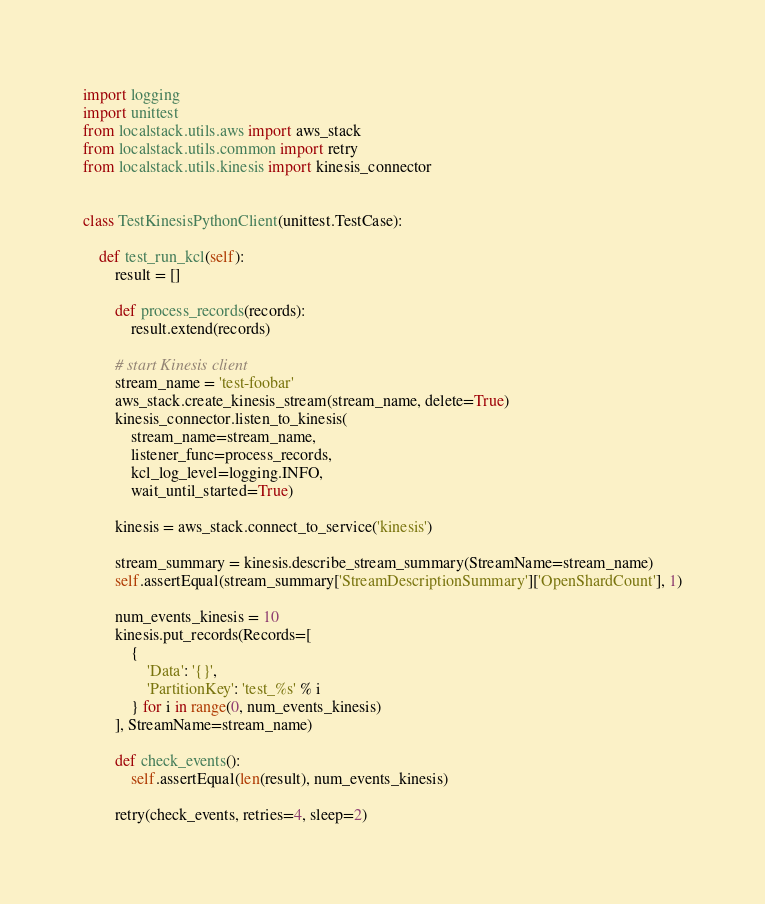<code> <loc_0><loc_0><loc_500><loc_500><_Python_>import logging
import unittest
from localstack.utils.aws import aws_stack
from localstack.utils.common import retry
from localstack.utils.kinesis import kinesis_connector


class TestKinesisPythonClient(unittest.TestCase):

    def test_run_kcl(self):
        result = []

        def process_records(records):
            result.extend(records)

        # start Kinesis client
        stream_name = 'test-foobar'
        aws_stack.create_kinesis_stream(stream_name, delete=True)
        kinesis_connector.listen_to_kinesis(
            stream_name=stream_name,
            listener_func=process_records,
            kcl_log_level=logging.INFO,
            wait_until_started=True)

        kinesis = aws_stack.connect_to_service('kinesis')

        stream_summary = kinesis.describe_stream_summary(StreamName=stream_name)
        self.assertEqual(stream_summary['StreamDescriptionSummary']['OpenShardCount'], 1)

        num_events_kinesis = 10
        kinesis.put_records(Records=[
            {
                'Data': '{}',
                'PartitionKey': 'test_%s' % i
            } for i in range(0, num_events_kinesis)
        ], StreamName=stream_name)

        def check_events():
            self.assertEqual(len(result), num_events_kinesis)

        retry(check_events, retries=4, sleep=2)
</code> 